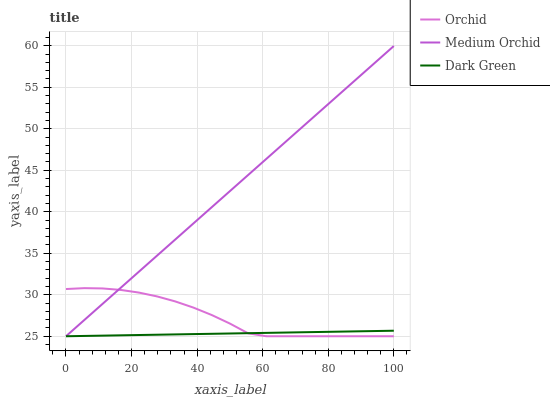Does Dark Green have the minimum area under the curve?
Answer yes or no. Yes. Does Medium Orchid have the maximum area under the curve?
Answer yes or no. Yes. Does Orchid have the minimum area under the curve?
Answer yes or no. No. Does Orchid have the maximum area under the curve?
Answer yes or no. No. Is Dark Green the smoothest?
Answer yes or no. Yes. Is Orchid the roughest?
Answer yes or no. Yes. Is Orchid the smoothest?
Answer yes or no. No. Is Dark Green the roughest?
Answer yes or no. No. Does Medium Orchid have the lowest value?
Answer yes or no. Yes. Does Medium Orchid have the highest value?
Answer yes or no. Yes. Does Orchid have the highest value?
Answer yes or no. No. Does Medium Orchid intersect Dark Green?
Answer yes or no. Yes. Is Medium Orchid less than Dark Green?
Answer yes or no. No. Is Medium Orchid greater than Dark Green?
Answer yes or no. No. 